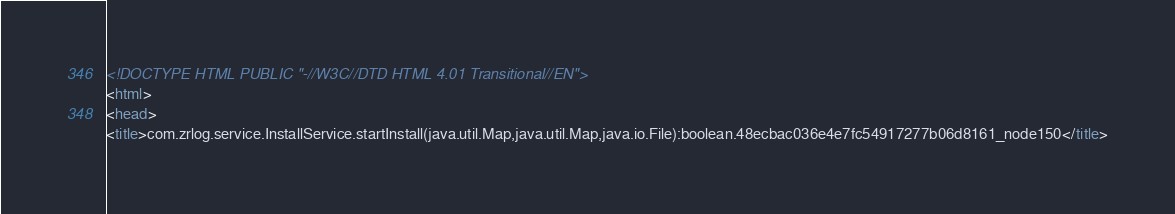<code> <loc_0><loc_0><loc_500><loc_500><_HTML_><!DOCTYPE HTML PUBLIC "-//W3C//DTD HTML 4.01 Transitional//EN">
<html>
<head>
<title>com.zrlog.service.InstallService.startInstall(java.util.Map,java.util.Map,java.io.File):boolean.48ecbac036e4e7fc54917277b06d8161_node150</title></code> 